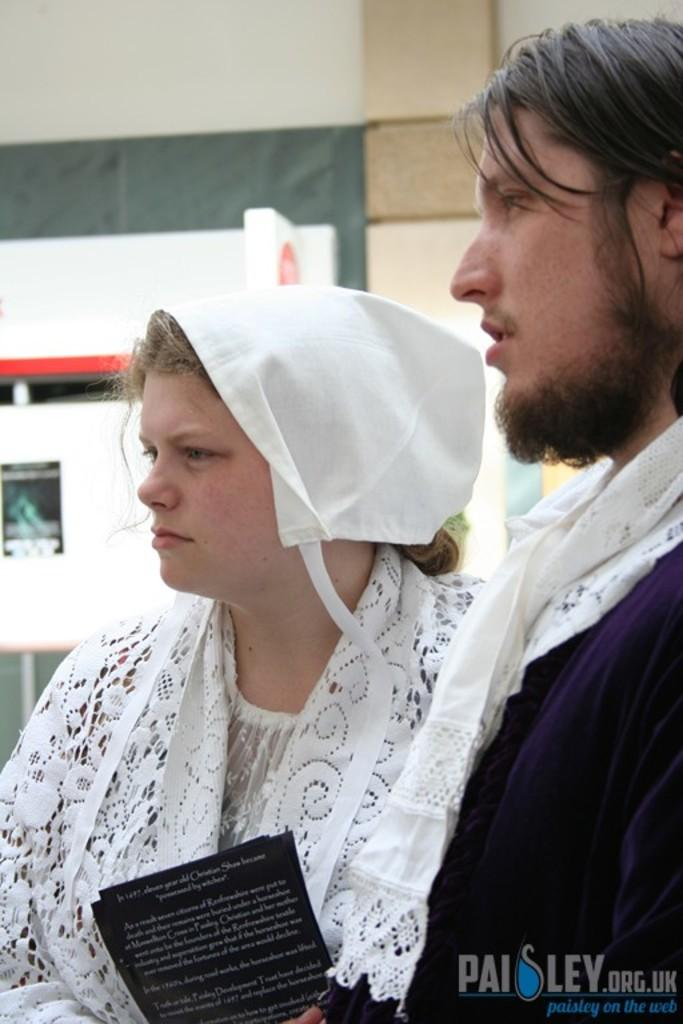Who is the main subject in the image? There is a woman in the image. What is the woman wearing? The woman is wearing a white dress. What is the woman holding in her hand? The woman is holding an object in her hand. Can you describe the other person in the image? There is another person standing beside the woman. What type of pollution can be seen in the image? There is no pollution visible in the image. Can you tell me how many hens are present in the image? There are no hens present in the image. 